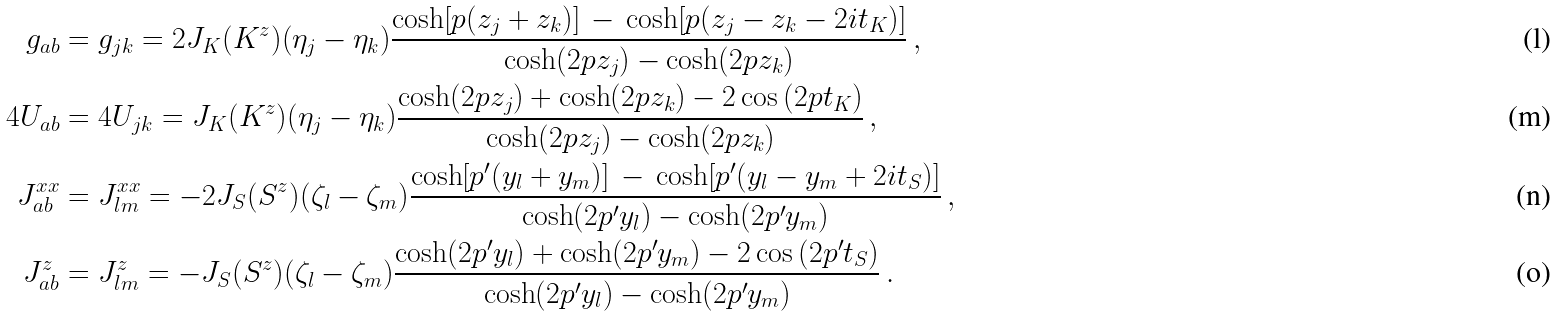Convert formula to latex. <formula><loc_0><loc_0><loc_500><loc_500>g _ { a b } & = g _ { j k } = 2 J _ { K } ( K ^ { z } ) { \left ( \eta _ { j } - \eta _ { k } \right ) } \frac { \cosh [ p ( z _ { j } + z _ { k } ) ] \, - \, \cosh [ p ( z _ { j } - z _ { k } - 2 i t _ { K } ) ] } { \cosh ( 2 p z _ { j } ) - \cosh ( 2 p z _ { k } ) } \, , \\ 4 U _ { a b } & = 4 U _ { j k } = J _ { K } ( K ^ { z } ) { ( \eta _ { j } - \eta _ { k } ) } \frac { \cosh ( 2 p z _ { j } ) + \cosh ( 2 p z _ { k } ) - 2 \cos { ( 2 p t _ { K } ) } } { \cosh ( 2 p z _ { j } ) - \cosh ( 2 p z _ { k } ) } \, , \\ J ^ { x x } _ { a b } & = J ^ { x x } _ { l m } = - 2 J _ { S } ( S ^ { z } ) { ( \zeta _ { l } - \zeta _ { m } ) } \frac { \cosh [ p ^ { \prime } ( y _ { l } + y _ { m } ) ] \, - \, \cosh [ p ^ { \prime } ( y _ { l } - y _ { m } + 2 i t _ { S } ) ] } { \cosh ( 2 p ^ { \prime } y _ { l } ) - \cosh ( 2 p ^ { \prime } y _ { m } ) } \, , \\ J ^ { z } _ { a b } & = J ^ { z } _ { l m } = - J _ { S } ( S ^ { z } ) { ( \zeta _ { l } - \zeta _ { m } ) } \frac { \cosh ( 2 p ^ { \prime } y _ { l } ) + \cosh ( 2 p ^ { \prime } y _ { m } ) - 2 \cos { ( 2 p ^ { \prime } t _ { S } ) } } { \cosh ( 2 p ^ { \prime } y _ { l } ) - \cosh ( 2 p ^ { \prime } y _ { m } ) } \, .</formula> 